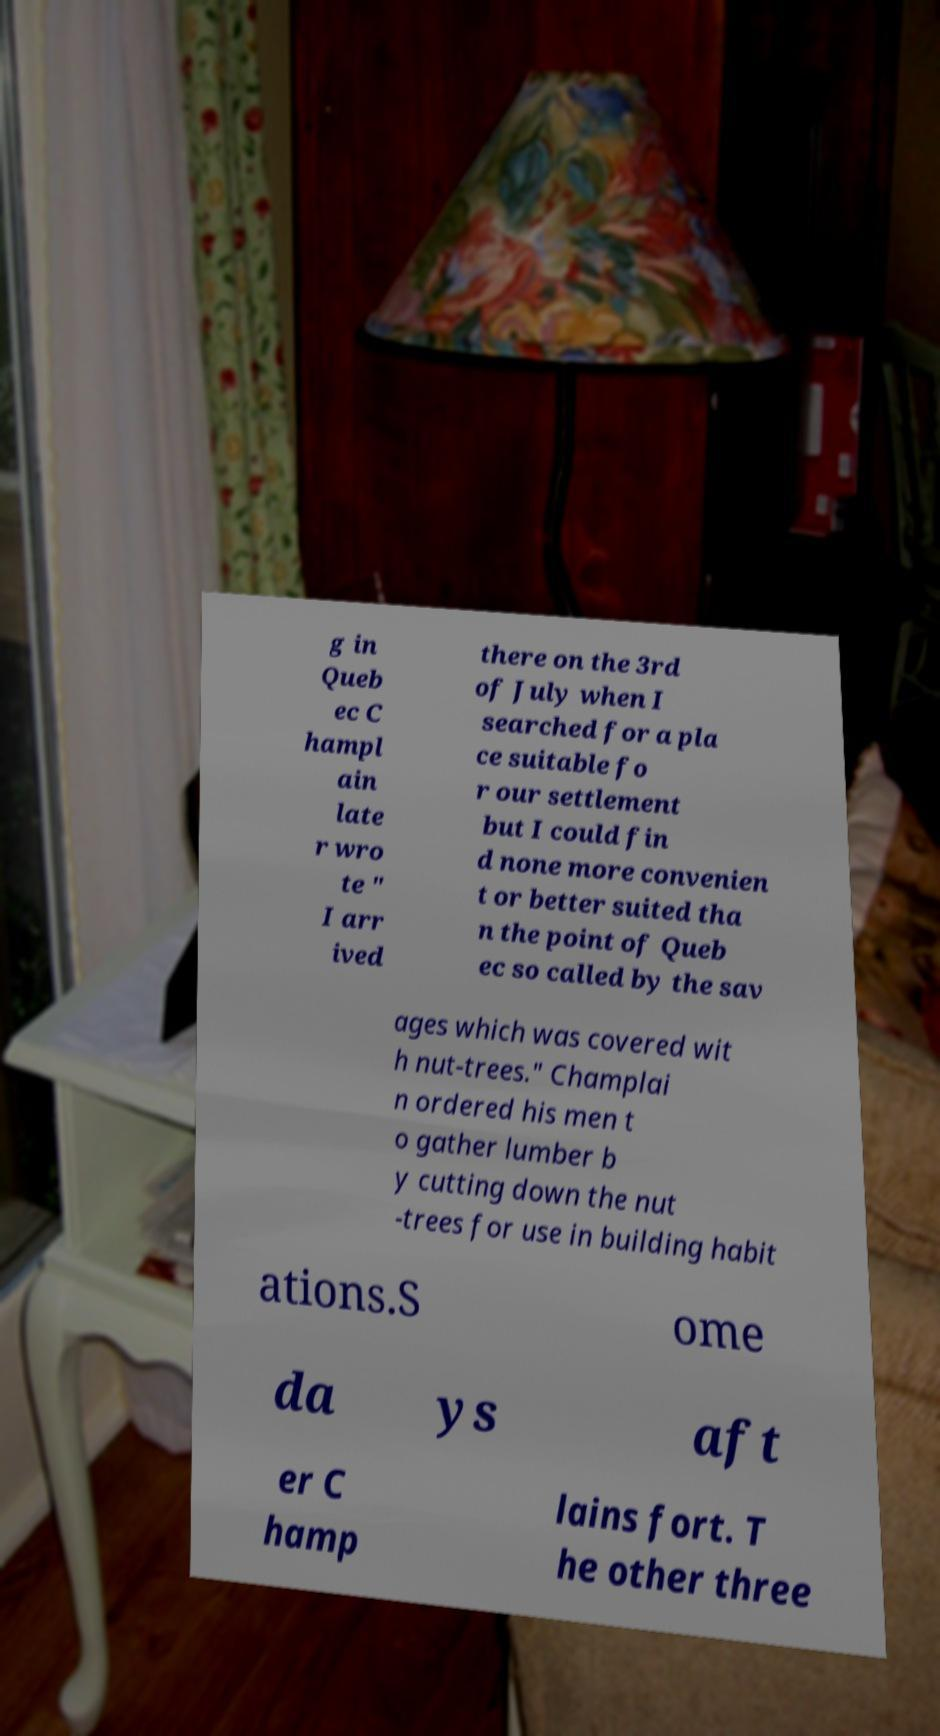Can you accurately transcribe the text from the provided image for me? g in Queb ec C hampl ain late r wro te " I arr ived there on the 3rd of July when I searched for a pla ce suitable fo r our settlement but I could fin d none more convenien t or better suited tha n the point of Queb ec so called by the sav ages which was covered wit h nut-trees." Champlai n ordered his men t o gather lumber b y cutting down the nut -trees for use in building habit ations.S ome da ys aft er C hamp lains fort. T he other three 